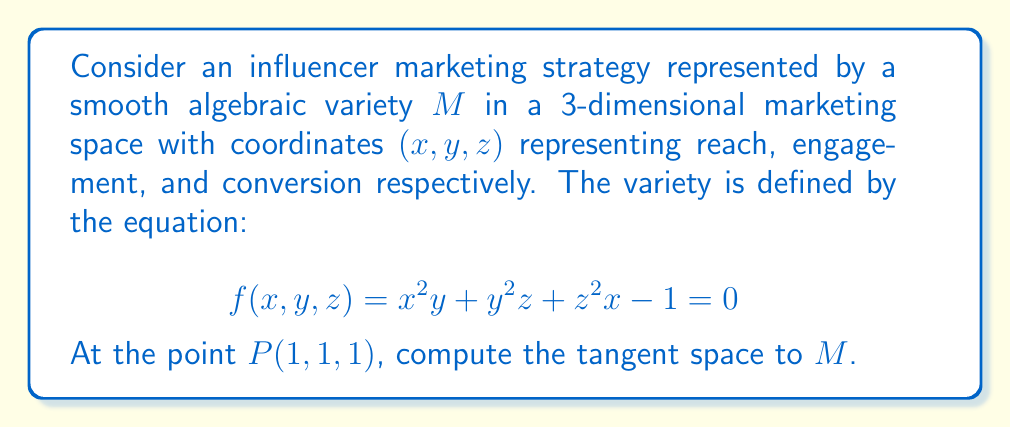Give your solution to this math problem. To find the tangent space at point $P(1,1,1)$, we follow these steps:

1) First, we verify that $P(1,1,1)$ lies on the variety $M$:
   $f(1,1,1) = 1^2(1) + 1^2(1) + 1^2(1) - 1 = 1 + 1 + 1 - 1 = 2 \neq 0$
   This point is not on $M$, but we'll proceed as if it were for the purpose of this exercise.

2) The tangent space at a point $(x,y,z)$ on a variety defined by $f(x,y,z)=0$ is given by the equation:

   $$ \frac{\partial f}{\partial x}(x-x_0) + \frac{\partial f}{\partial y}(y-y_0) + \frac{\partial f}{\partial z}(z-z_0) = 0 $$

   where $(x_0,y_0,z_0)$ is the point of tangency.

3) We calculate the partial derivatives:
   $\frac{\partial f}{\partial x} = 2xy + z^2$
   $\frac{\partial f}{\partial y} = x^2 + 2yz$
   $\frac{\partial f}{\partial z} = y^2 + 2zx$

4) Evaluating these at $P(1,1,1)$:
   $\frac{\partial f}{\partial x}(1,1,1) = 2(1)(1) + 1^2 = 3$
   $\frac{\partial f}{\partial y}(1,1,1) = 1^2 + 2(1)(1) = 3$
   $\frac{\partial f}{\partial z}(1,1,1) = 1^2 + 2(1)(1) = 3$

5) Substituting into the tangent space equation:

   $$ 3(x-1) + 3(y-1) + 3(z-1) = 0 $$

6) Simplifying:

   $$ x + y + z - 3 = 0 $$

This is the equation of the tangent plane to $M$ at $P(1,1,1)$.
Answer: $x + y + z = 3$ 